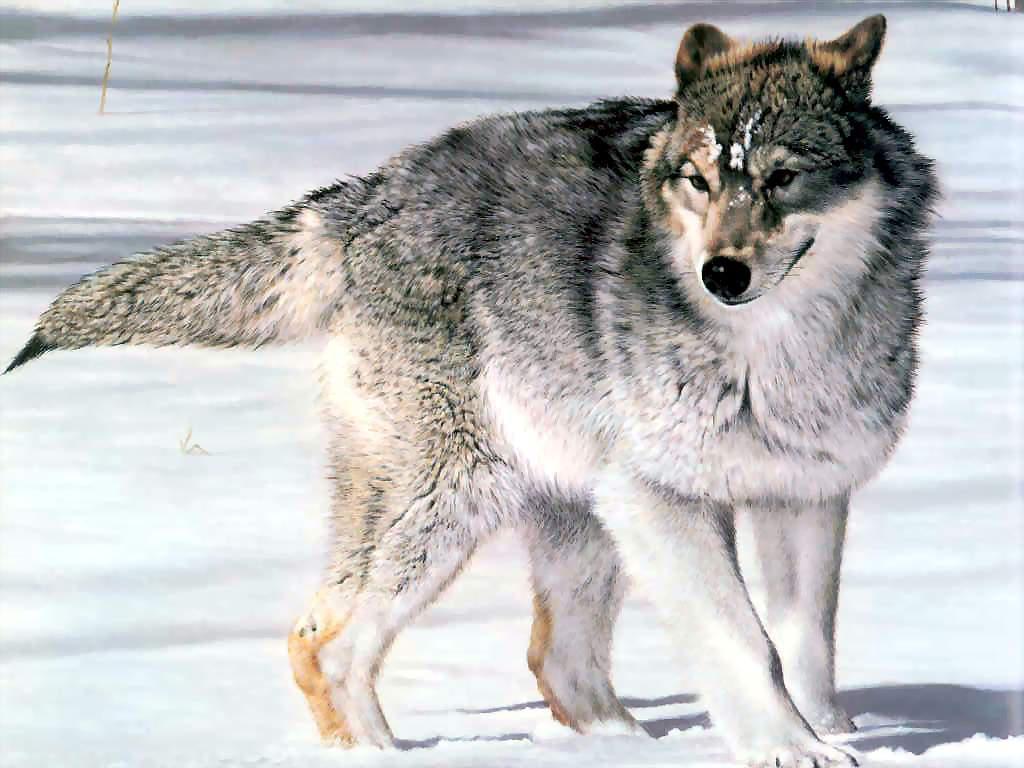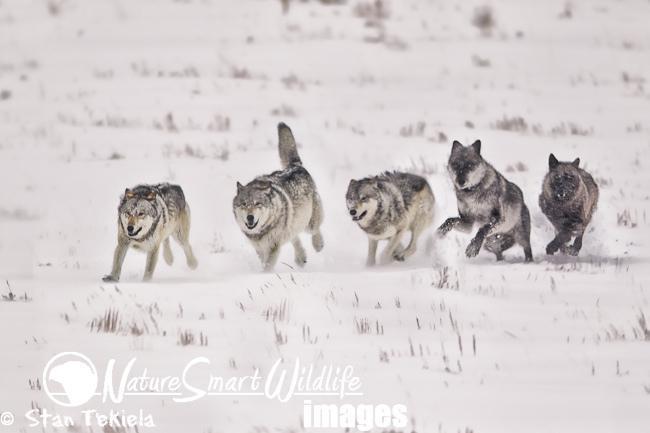The first image is the image on the left, the second image is the image on the right. Assess this claim about the two images: "There is a single dog in one image and multiple dogs in the other image.". Correct or not? Answer yes or no. Yes. The first image is the image on the left, the second image is the image on the right. Given the left and right images, does the statement "There is only one wolf in one of the images." hold true? Answer yes or no. Yes. 